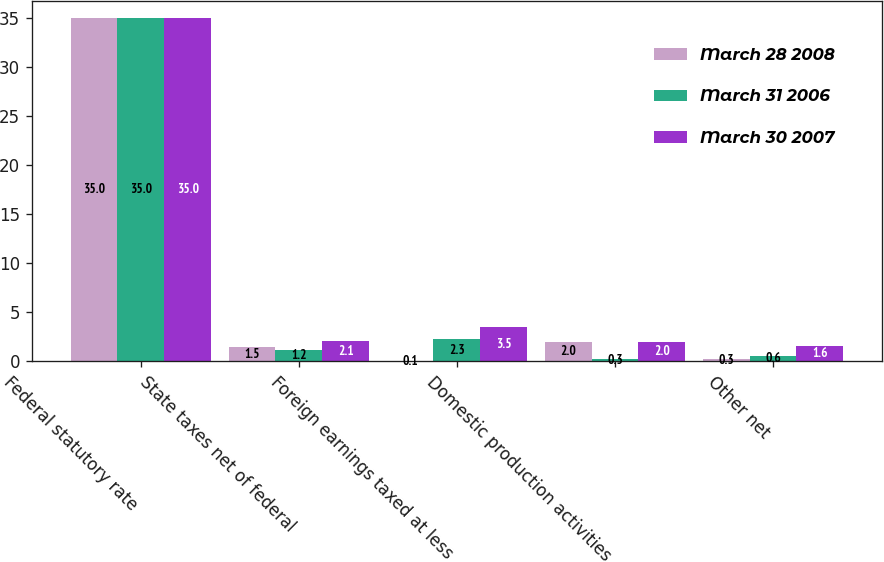<chart> <loc_0><loc_0><loc_500><loc_500><stacked_bar_chart><ecel><fcel>Federal statutory rate<fcel>State taxes net of federal<fcel>Foreign earnings taxed at less<fcel>Domestic production activities<fcel>Other net<nl><fcel>March 28 2008<fcel>35<fcel>1.5<fcel>0.1<fcel>2<fcel>0.3<nl><fcel>March 31 2006<fcel>35<fcel>1.2<fcel>2.3<fcel>0.3<fcel>0.6<nl><fcel>March 30 2007<fcel>35<fcel>2.1<fcel>3.5<fcel>2<fcel>1.6<nl></chart> 